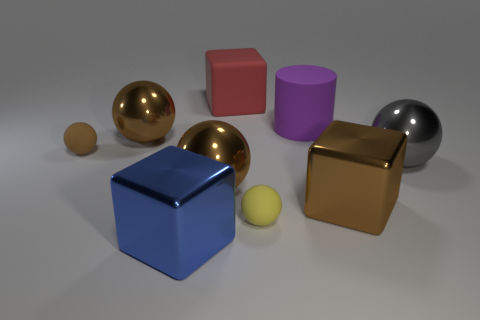Does the red object have the same material as the brown ball right of the blue metallic cube?
Offer a very short reply. No. There is a gray thing that is the same shape as the brown matte thing; what is it made of?
Provide a short and direct response. Metal. Are there more gray shiny balls to the right of the red thing than large red blocks in front of the yellow rubber sphere?
Provide a succinct answer. Yes. There is a large blue object that is made of the same material as the brown cube; what is its shape?
Your response must be concise. Cube. How many other things are the same shape as the big gray object?
Ensure brevity in your answer.  4. There is a thing that is in front of the yellow thing; what is its shape?
Your answer should be compact. Cube. What is the color of the large cylinder?
Your answer should be very brief. Purple. How many other things are the same size as the brown metal cube?
Provide a succinct answer. 6. What material is the gray ball that is right of the brown shiny object left of the large blue metallic thing?
Your answer should be very brief. Metal. Does the purple matte cylinder have the same size as the matte ball that is on the left side of the big blue metallic cube?
Offer a terse response. No. 